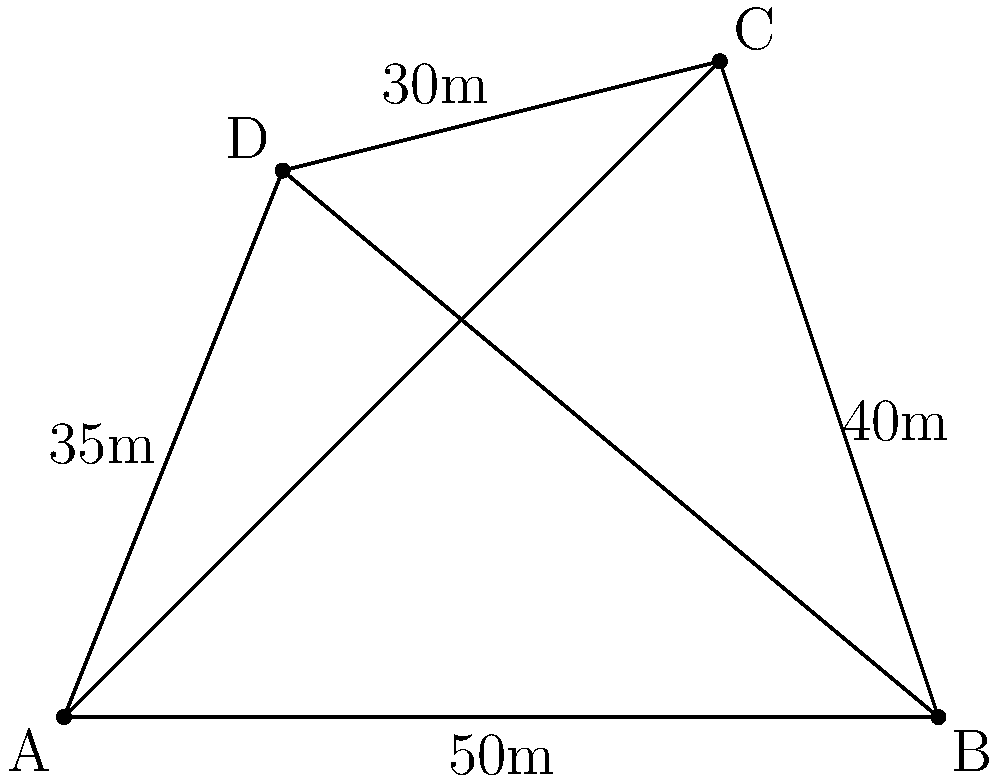While setting up camp in a remote area of Madagascar, you need to calculate the area of your irregular-shaped campsite. You measure the sides and one diagonal: AB = 50m, BC = 40m, CD = 30m, DA = 35m, and AC (diagonal) = 70m. What is the total area of your campsite in square meters? To find the area of the irregular-shaped campsite, we can use triangulation by dividing it into two triangles: ABC and ACD.

Step 1: Calculate the area of triangle ABC using Heron's formula.
Let $s_1$ be the semi-perimeter of triangle ABC:
$s_1 = \frac{AB + BC + AC}{2} = \frac{50 + 40 + 70}{2} = 80$

Area of triangle ABC:
$A_1 = \sqrt{s_1(s_1-AB)(s_1-BC)(s_1-AC)}$
$A_1 = \sqrt{80(80-50)(80-40)(80-70)}$
$A_1 = \sqrt{80 \cdot 30 \cdot 40 \cdot 10}$
$A_1 = \sqrt{960000} = 979.80$ sq m

Step 2: Calculate the area of triangle ACD using Heron's formula.
Let $s_2$ be the semi-perimeter of triangle ACD:
$s_2 = \frac{AC + CD + DA}{2} = \frac{70 + 30 + 35}{2} = 67.5$

Area of triangle ACD:
$A_2 = \sqrt{s_2(s_2-AC)(s_2-CD)(s_2-DA)}$
$A_2 = \sqrt{67.5(67.5-70)(67.5-30)(67.5-35)}$
$A_2 = \sqrt{67.5 \cdot (-2.5) \cdot 37.5 \cdot 32.5}$
$A_2 = \sqrt{206718.75} = 454.66$ sq m

Step 3: Calculate the total area by adding the areas of both triangles.
Total Area = $A_1 + A_2 = 979.80 + 454.66 = 1434.46$ sq m
Answer: 1434.46 sq m 